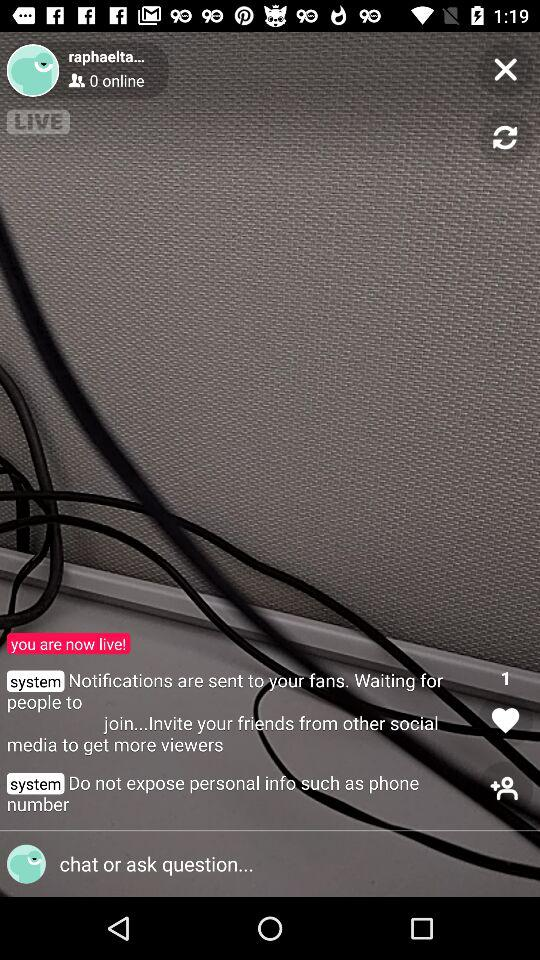Could you suggest ways to attract more viewers to this live stream? Certainly! To attract more viewers, the streamer could promote their live session on other social media platforms, engage with the audience by asking questions or discussing interesting topics, and ensure high-quality content. Collaborations with other creators and scheduling streams during peak hours might also help increase viewership. 